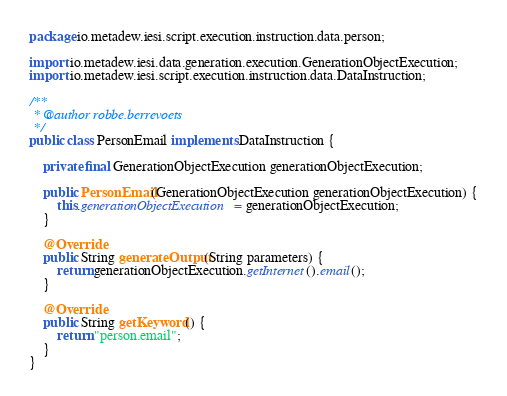<code> <loc_0><loc_0><loc_500><loc_500><_Java_>package io.metadew.iesi.script.execution.instruction.data.person;

import io.metadew.iesi.data.generation.execution.GenerationObjectExecution;
import io.metadew.iesi.script.execution.instruction.data.DataInstruction;

/**
 * @author robbe.berrevoets
 */
public class PersonEmail implements DataInstruction {

    private final GenerationObjectExecution generationObjectExecution;

    public PersonEmail(GenerationObjectExecution generationObjectExecution) {
        this.generationObjectExecution = generationObjectExecution;
    }

    @Override
    public String generateOutput(String parameters) {
        return generationObjectExecution.getInternet().email();
    }

    @Override
    public String getKeyword() {
        return "person.email";
    }
}</code> 